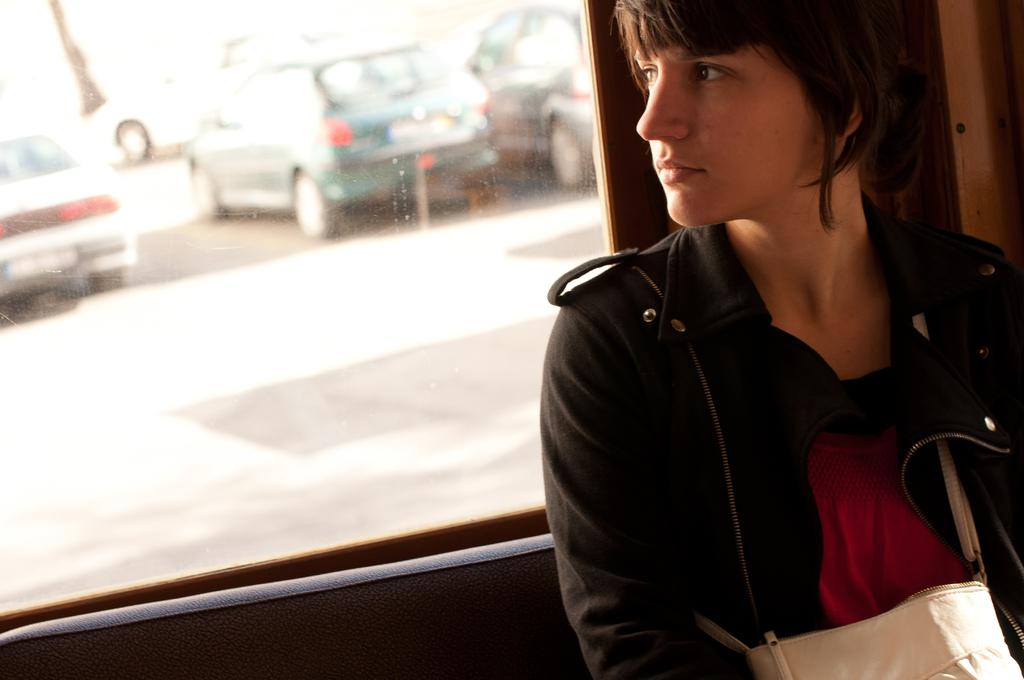What is the woman in the image wearing? The woman in the image is wearing a black jacket. How is the woman in the image being emphasized? The woman is highlighted in the image. What can be seen through the window in the image? Vehicles on a road are visible through the window. What grade does the woman in the image give to the book she is holding? There is no book visible in the image, so it is impossible to determine a grade. 